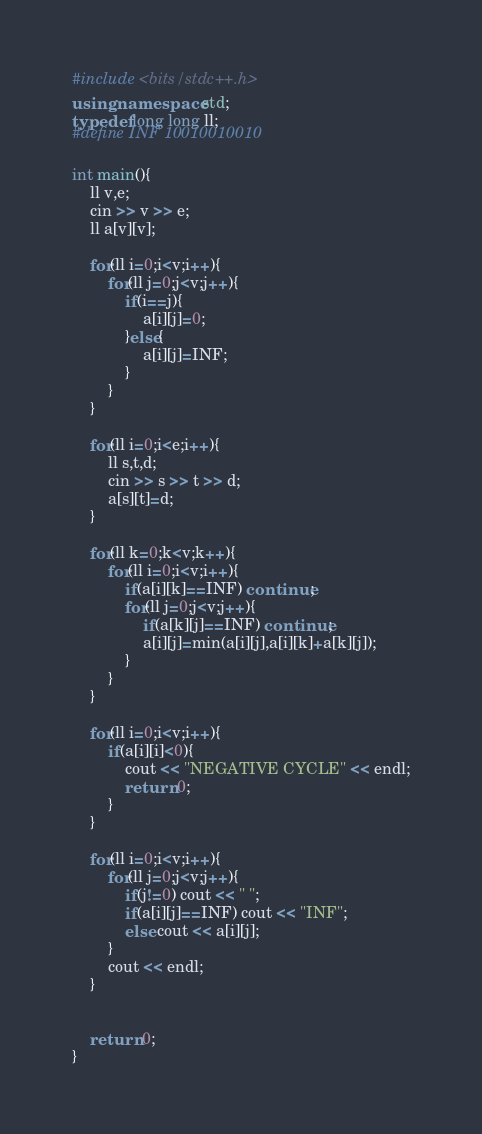<code> <loc_0><loc_0><loc_500><loc_500><_C++_>#include <bits/stdc++.h>
using namespace std;
typedef long long ll;
#define INF 10010010010

int main(){
    ll v,e;
    cin >> v >> e;
    ll a[v][v];
    
    for(ll i=0;i<v;i++){
        for(ll j=0;j<v;j++){
            if(i==j){
                a[i][j]=0;
            }else{
                a[i][j]=INF;
            }
        }
    }
    
    for(ll i=0;i<e;i++){
        ll s,t,d;
        cin >> s >> t >> d;
        a[s][t]=d;
    }
    
    for(ll k=0;k<v;k++){
        for(ll i=0;i<v;i++){
            if(a[i][k]==INF) continue;
            for(ll j=0;j<v;j++){
                if(a[k][j]==INF) continue;
                a[i][j]=min(a[i][j],a[i][k]+a[k][j]);
            }
        }
    }
    
    for(ll i=0;i<v;i++){
        if(a[i][i]<0){
            cout << "NEGATIVE CYCLE" << endl;
            return 0;
        }
    }
    
    for(ll i=0;i<v;i++){
        for(ll j=0;j<v;j++){
            if(j!=0) cout << " ";
            if(a[i][j]==INF) cout << "INF";
            else cout << a[i][j];
        }
        cout << endl;
    }
    
    
    return 0;
}








</code> 